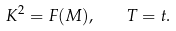Convert formula to latex. <formula><loc_0><loc_0><loc_500><loc_500>K ^ { 2 } = F ( M ) , \quad T = t .</formula> 